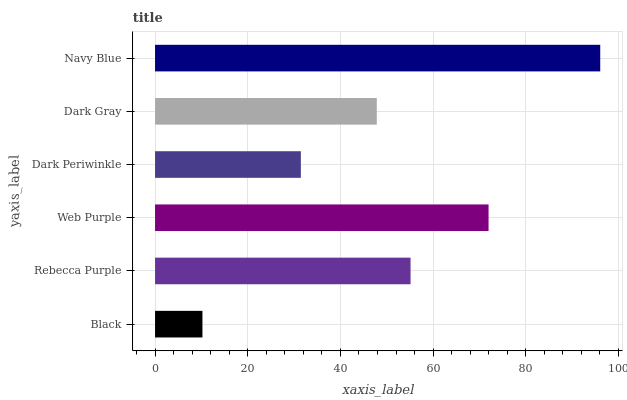Is Black the minimum?
Answer yes or no. Yes. Is Navy Blue the maximum?
Answer yes or no. Yes. Is Rebecca Purple the minimum?
Answer yes or no. No. Is Rebecca Purple the maximum?
Answer yes or no. No. Is Rebecca Purple greater than Black?
Answer yes or no. Yes. Is Black less than Rebecca Purple?
Answer yes or no. Yes. Is Black greater than Rebecca Purple?
Answer yes or no. No. Is Rebecca Purple less than Black?
Answer yes or no. No. Is Rebecca Purple the high median?
Answer yes or no. Yes. Is Dark Gray the low median?
Answer yes or no. Yes. Is Black the high median?
Answer yes or no. No. Is Web Purple the low median?
Answer yes or no. No. 